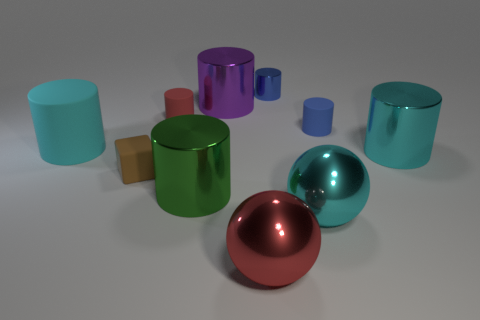Subtract all red cylinders. How many cylinders are left? 6 Subtract all green cylinders. How many cylinders are left? 6 Subtract all blue cylinders. Subtract all purple spheres. How many cylinders are left? 5 Subtract all balls. How many objects are left? 8 Subtract all big yellow matte cubes. Subtract all large matte things. How many objects are left? 9 Add 2 big shiny objects. How many big shiny objects are left? 7 Add 9 tiny red rubber cylinders. How many tiny red rubber cylinders exist? 10 Subtract 1 cyan spheres. How many objects are left? 9 